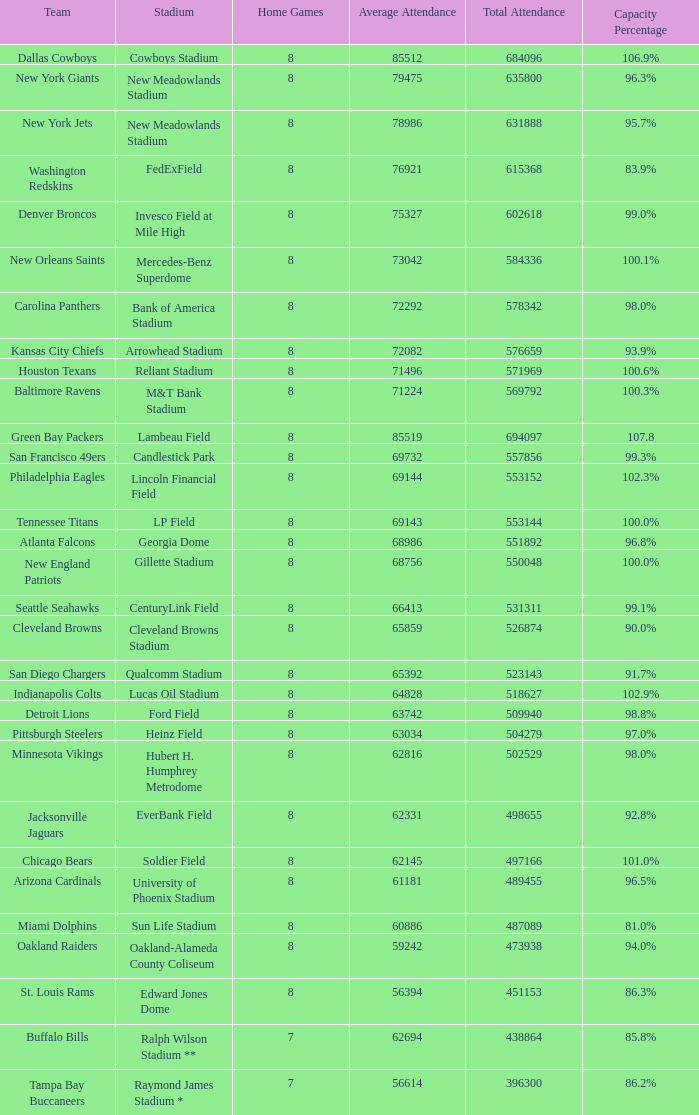What does the average attendance amount to when the capacity percentage is 96.5%? 1.0. 